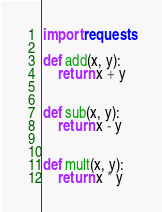Convert code to text. <code><loc_0><loc_0><loc_500><loc_500><_Python_>import requests

def add(x, y):
    return x + y


def sub(x, y):
    return x - y


def mult(x, y):
    return x * y
</code> 